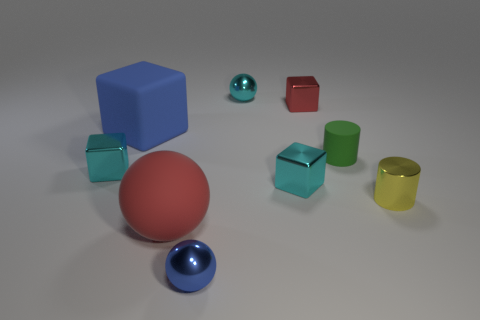Is the number of tiny cyan blocks on the right side of the big red thing the same as the number of tiny shiny cubes?
Your answer should be compact. No. What shape is the green object?
Your answer should be compact. Cylinder. Are there any other things that have the same color as the small rubber cylinder?
Provide a short and direct response. No. Is the size of the blue object in front of the tiny yellow shiny cylinder the same as the cyan object behind the tiny rubber thing?
Offer a very short reply. Yes. The small yellow object right of the red object that is right of the blue shiny sphere is what shape?
Provide a succinct answer. Cylinder. Do the blue metal object and the cyan object that is behind the matte cylinder have the same size?
Your answer should be very brief. Yes. How big is the cylinder behind the cyan shiny object on the right side of the ball behind the big matte block?
Your answer should be compact. Small. How many things are small objects behind the big rubber block or tiny blue spheres?
Your answer should be compact. 3. What number of large objects are in front of the tiny rubber object on the right side of the matte ball?
Ensure brevity in your answer.  1. Is the number of red rubber balls behind the blue metal sphere greater than the number of red metal objects?
Keep it short and to the point. No. 